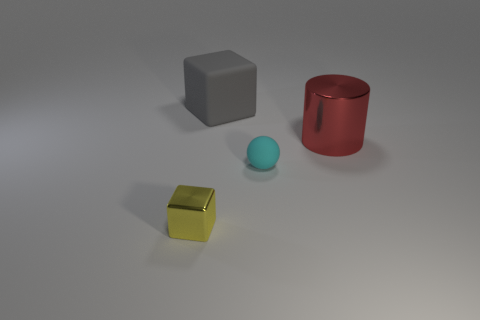Is there anything else that has the same shape as the large gray rubber object?
Provide a succinct answer. Yes. What color is the sphere that is made of the same material as the large gray thing?
Your answer should be compact. Cyan. There is a metal thing that is to the right of the cube in front of the big red thing; are there any cyan rubber balls behind it?
Offer a terse response. No. Are there fewer tiny metallic objects that are on the right side of the cyan rubber sphere than big red cylinders in front of the big shiny cylinder?
Your answer should be compact. No. How many small cyan spheres have the same material as the gray thing?
Provide a succinct answer. 1. Do the cyan matte ball and the cube to the right of the yellow shiny block have the same size?
Offer a very short reply. No. What is the size of the cube that is behind the metallic object right of the large thing that is behind the red metallic cylinder?
Offer a very short reply. Large. Is the number of small cubes that are behind the sphere greater than the number of tiny spheres that are on the left side of the rubber block?
Your response must be concise. No. How many yellow things are to the left of the metallic thing on the left side of the gray cube?
Give a very brief answer. 0. Is there a matte thing of the same color as the ball?
Your answer should be very brief. No. 